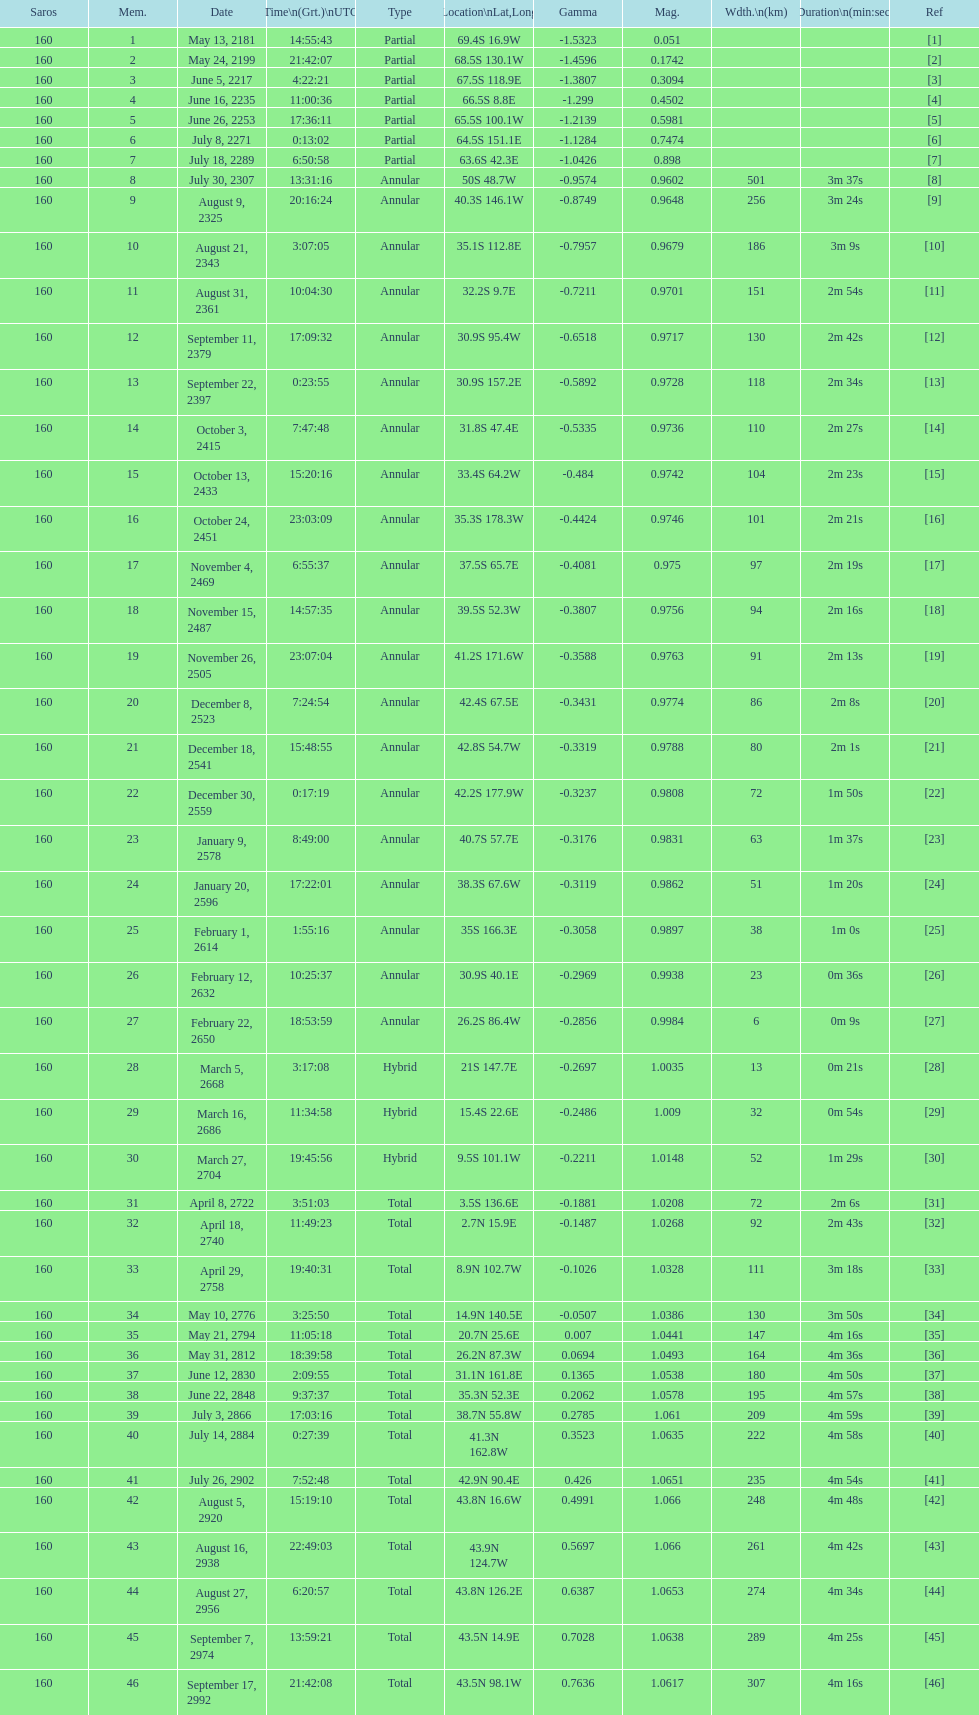How long did 18 last? 2m 16s. 